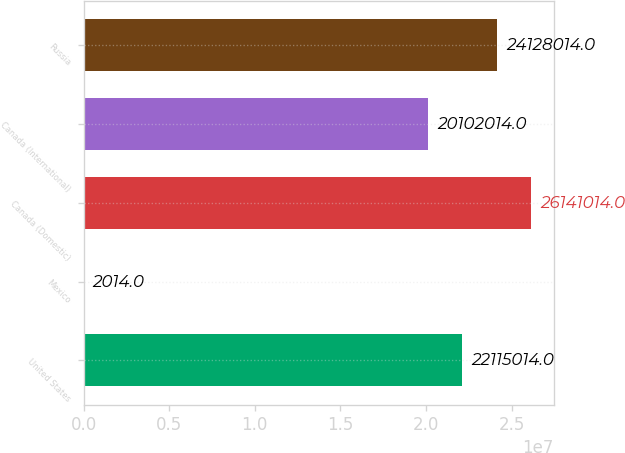Convert chart to OTSL. <chart><loc_0><loc_0><loc_500><loc_500><bar_chart><fcel>United States<fcel>Mexico<fcel>Canada (Domestic)<fcel>Canada (International)<fcel>Russia<nl><fcel>2.2115e+07<fcel>2014<fcel>2.6141e+07<fcel>2.0102e+07<fcel>2.4128e+07<nl></chart> 